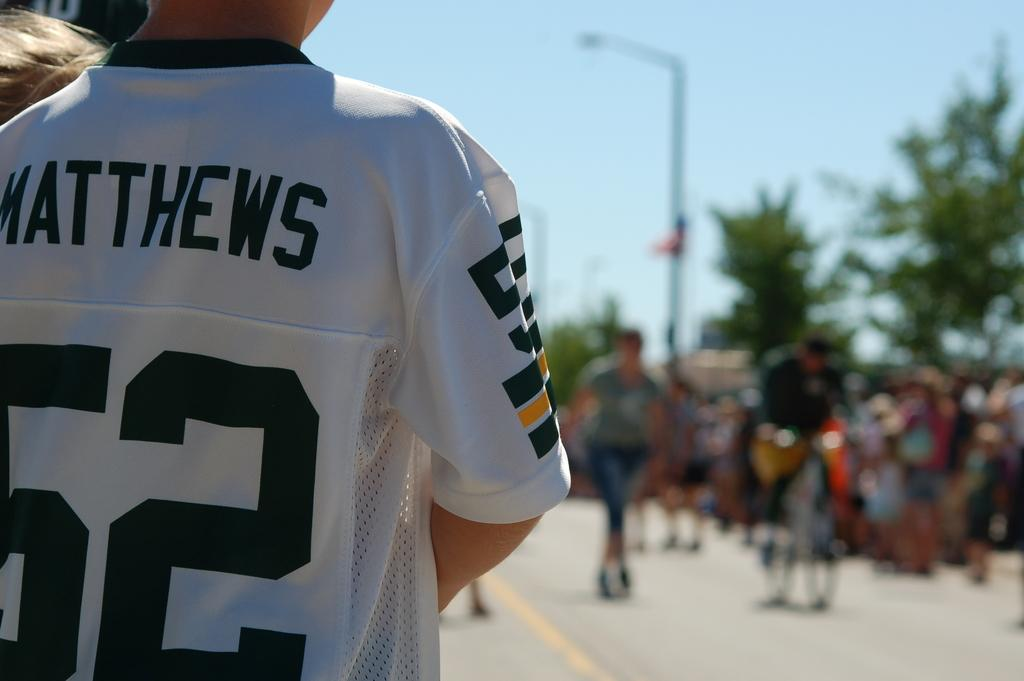<image>
Offer a succinct explanation of the picture presented. A kid in a white jersey with the number 52 